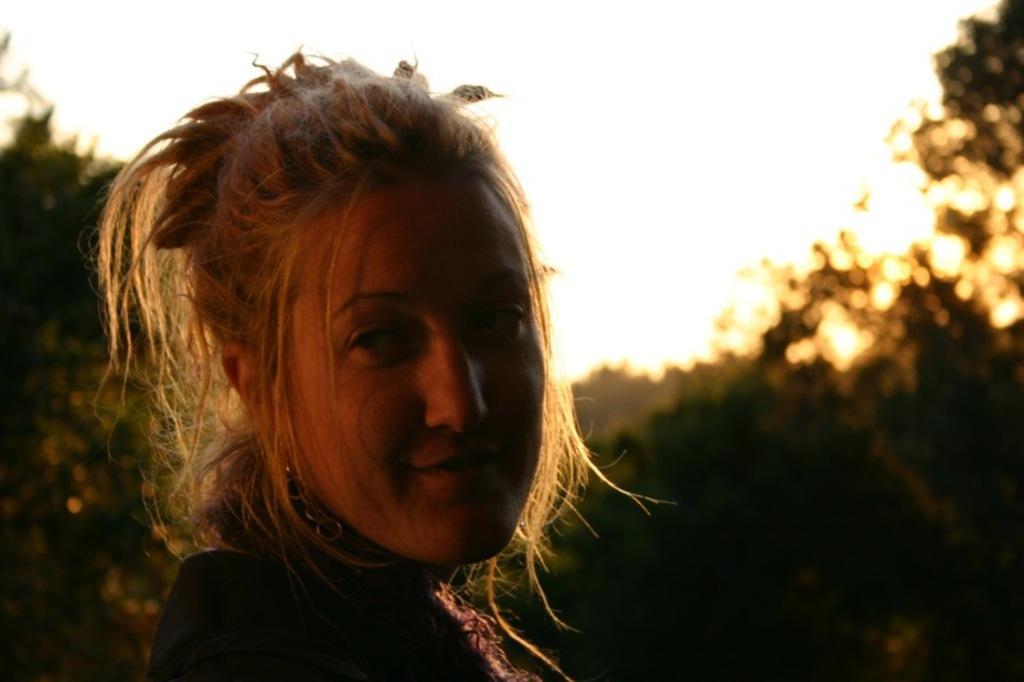Please provide a concise description of this image. In this picture we can observe a woman. She is smiling. In the background there are trees and a sky. 